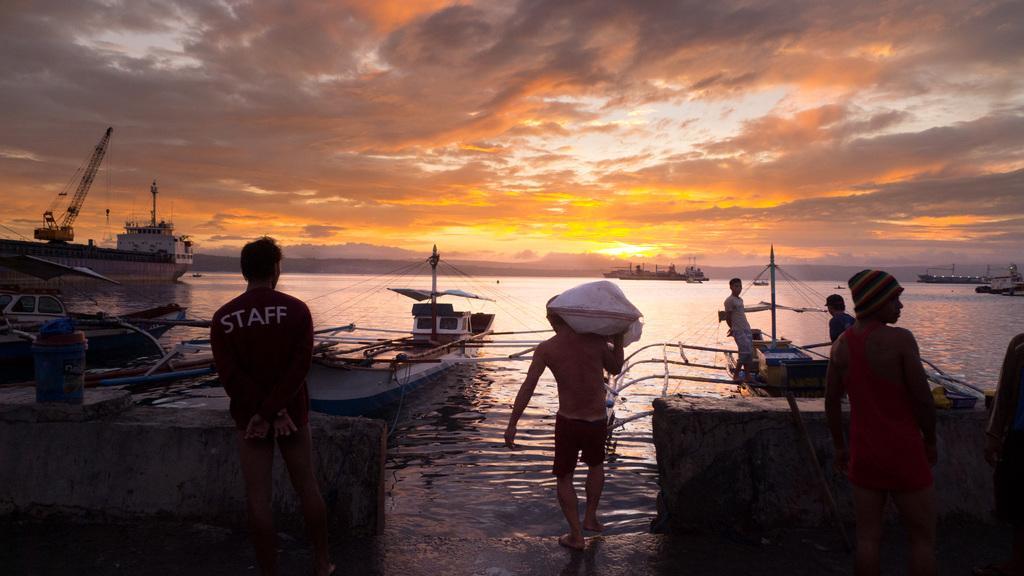Describe this image in one or two sentences. In this picture I can see boats, water and a cloudy sky and I can see few people are standing and a human walking and carrying something on his shoulder and I can see couple of them standing on the boat. 